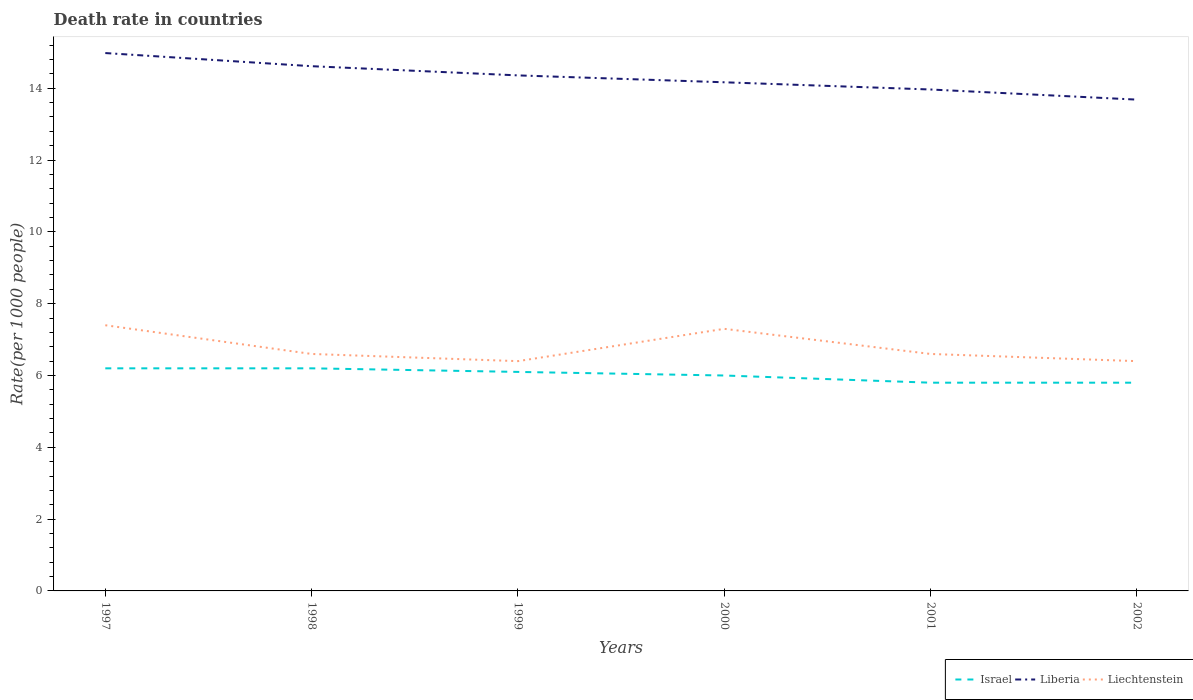How many different coloured lines are there?
Offer a terse response. 3. Is the number of lines equal to the number of legend labels?
Offer a very short reply. Yes. Across all years, what is the maximum death rate in Israel?
Ensure brevity in your answer.  5.8. In which year was the death rate in Israel maximum?
Ensure brevity in your answer.  2001. What is the total death rate in Liechtenstein in the graph?
Offer a very short reply. 0.1. What is the difference between the highest and the second highest death rate in Liberia?
Offer a very short reply. 1.3. What is the difference between the highest and the lowest death rate in Liberia?
Provide a succinct answer. 3. How many lines are there?
Keep it short and to the point. 3. Are the values on the major ticks of Y-axis written in scientific E-notation?
Your answer should be compact. No. Where does the legend appear in the graph?
Offer a very short reply. Bottom right. How many legend labels are there?
Provide a succinct answer. 3. What is the title of the graph?
Offer a terse response. Death rate in countries. Does "Iran" appear as one of the legend labels in the graph?
Your answer should be very brief. No. What is the label or title of the Y-axis?
Provide a short and direct response. Rate(per 1000 people). What is the Rate(per 1000 people) of Liberia in 1997?
Ensure brevity in your answer.  14.98. What is the Rate(per 1000 people) of Liechtenstein in 1997?
Make the answer very short. 7.4. What is the Rate(per 1000 people) in Israel in 1998?
Offer a terse response. 6.2. What is the Rate(per 1000 people) of Liberia in 1998?
Your response must be concise. 14.62. What is the Rate(per 1000 people) of Liberia in 1999?
Your answer should be very brief. 14.36. What is the Rate(per 1000 people) of Liechtenstein in 1999?
Offer a very short reply. 6.4. What is the Rate(per 1000 people) in Liberia in 2000?
Your answer should be very brief. 14.17. What is the Rate(per 1000 people) of Liechtenstein in 2000?
Provide a succinct answer. 7.3. What is the Rate(per 1000 people) of Israel in 2001?
Keep it short and to the point. 5.8. What is the Rate(per 1000 people) of Liberia in 2001?
Your answer should be very brief. 13.97. What is the Rate(per 1000 people) of Liechtenstein in 2001?
Ensure brevity in your answer.  6.6. What is the Rate(per 1000 people) in Israel in 2002?
Offer a very short reply. 5.8. What is the Rate(per 1000 people) of Liberia in 2002?
Provide a succinct answer. 13.68. What is the Rate(per 1000 people) in Liechtenstein in 2002?
Ensure brevity in your answer.  6.4. Across all years, what is the maximum Rate(per 1000 people) of Liberia?
Offer a very short reply. 14.98. Across all years, what is the maximum Rate(per 1000 people) in Liechtenstein?
Provide a short and direct response. 7.4. Across all years, what is the minimum Rate(per 1000 people) of Liberia?
Your response must be concise. 13.68. Across all years, what is the minimum Rate(per 1000 people) of Liechtenstein?
Give a very brief answer. 6.4. What is the total Rate(per 1000 people) in Israel in the graph?
Your response must be concise. 36.1. What is the total Rate(per 1000 people) of Liberia in the graph?
Ensure brevity in your answer.  85.77. What is the total Rate(per 1000 people) in Liechtenstein in the graph?
Your answer should be very brief. 40.7. What is the difference between the Rate(per 1000 people) of Liberia in 1997 and that in 1998?
Your answer should be very brief. 0.37. What is the difference between the Rate(per 1000 people) in Liechtenstein in 1997 and that in 1998?
Keep it short and to the point. 0.8. What is the difference between the Rate(per 1000 people) of Israel in 1997 and that in 1999?
Make the answer very short. 0.1. What is the difference between the Rate(per 1000 people) in Liberia in 1997 and that in 1999?
Provide a short and direct response. 0.62. What is the difference between the Rate(per 1000 people) of Liechtenstein in 1997 and that in 1999?
Offer a terse response. 1. What is the difference between the Rate(per 1000 people) of Israel in 1997 and that in 2000?
Ensure brevity in your answer.  0.2. What is the difference between the Rate(per 1000 people) in Liberia in 1997 and that in 2000?
Give a very brief answer. 0.81. What is the difference between the Rate(per 1000 people) of Israel in 1997 and that in 2001?
Ensure brevity in your answer.  0.4. What is the difference between the Rate(per 1000 people) in Liberia in 1997 and that in 2001?
Make the answer very short. 1.01. What is the difference between the Rate(per 1000 people) in Liechtenstein in 1997 and that in 2001?
Offer a terse response. 0.8. What is the difference between the Rate(per 1000 people) in Israel in 1997 and that in 2002?
Ensure brevity in your answer.  0.4. What is the difference between the Rate(per 1000 people) in Liberia in 1997 and that in 2002?
Provide a short and direct response. 1.3. What is the difference between the Rate(per 1000 people) in Liberia in 1998 and that in 1999?
Give a very brief answer. 0.26. What is the difference between the Rate(per 1000 people) of Liechtenstein in 1998 and that in 1999?
Make the answer very short. 0.2. What is the difference between the Rate(per 1000 people) of Liberia in 1998 and that in 2000?
Give a very brief answer. 0.45. What is the difference between the Rate(per 1000 people) in Israel in 1998 and that in 2001?
Your answer should be compact. 0.4. What is the difference between the Rate(per 1000 people) in Liberia in 1998 and that in 2001?
Offer a very short reply. 0.65. What is the difference between the Rate(per 1000 people) of Liberia in 1999 and that in 2000?
Give a very brief answer. 0.19. What is the difference between the Rate(per 1000 people) in Liberia in 1999 and that in 2001?
Provide a succinct answer. 0.39. What is the difference between the Rate(per 1000 people) in Israel in 1999 and that in 2002?
Give a very brief answer. 0.3. What is the difference between the Rate(per 1000 people) in Liberia in 1999 and that in 2002?
Provide a succinct answer. 0.68. What is the difference between the Rate(per 1000 people) of Liechtenstein in 1999 and that in 2002?
Your response must be concise. 0. What is the difference between the Rate(per 1000 people) in Liberia in 2000 and that in 2001?
Provide a succinct answer. 0.2. What is the difference between the Rate(per 1000 people) in Israel in 2000 and that in 2002?
Offer a very short reply. 0.2. What is the difference between the Rate(per 1000 people) in Liberia in 2000 and that in 2002?
Your answer should be very brief. 0.48. What is the difference between the Rate(per 1000 people) of Liberia in 2001 and that in 2002?
Give a very brief answer. 0.28. What is the difference between the Rate(per 1000 people) in Liechtenstein in 2001 and that in 2002?
Provide a succinct answer. 0.2. What is the difference between the Rate(per 1000 people) of Israel in 1997 and the Rate(per 1000 people) of Liberia in 1998?
Offer a very short reply. -8.41. What is the difference between the Rate(per 1000 people) of Israel in 1997 and the Rate(per 1000 people) of Liechtenstein in 1998?
Give a very brief answer. -0.4. What is the difference between the Rate(per 1000 people) of Liberia in 1997 and the Rate(per 1000 people) of Liechtenstein in 1998?
Your answer should be compact. 8.38. What is the difference between the Rate(per 1000 people) in Israel in 1997 and the Rate(per 1000 people) in Liberia in 1999?
Your answer should be compact. -8.16. What is the difference between the Rate(per 1000 people) in Israel in 1997 and the Rate(per 1000 people) in Liechtenstein in 1999?
Offer a terse response. -0.2. What is the difference between the Rate(per 1000 people) in Liberia in 1997 and the Rate(per 1000 people) in Liechtenstein in 1999?
Offer a very short reply. 8.58. What is the difference between the Rate(per 1000 people) of Israel in 1997 and the Rate(per 1000 people) of Liberia in 2000?
Provide a succinct answer. -7.97. What is the difference between the Rate(per 1000 people) in Israel in 1997 and the Rate(per 1000 people) in Liechtenstein in 2000?
Give a very brief answer. -1.1. What is the difference between the Rate(per 1000 people) of Liberia in 1997 and the Rate(per 1000 people) of Liechtenstein in 2000?
Keep it short and to the point. 7.68. What is the difference between the Rate(per 1000 people) of Israel in 1997 and the Rate(per 1000 people) of Liberia in 2001?
Offer a terse response. -7.77. What is the difference between the Rate(per 1000 people) in Liberia in 1997 and the Rate(per 1000 people) in Liechtenstein in 2001?
Your answer should be compact. 8.38. What is the difference between the Rate(per 1000 people) in Israel in 1997 and the Rate(per 1000 people) in Liberia in 2002?
Make the answer very short. -7.48. What is the difference between the Rate(per 1000 people) in Israel in 1997 and the Rate(per 1000 people) in Liechtenstein in 2002?
Keep it short and to the point. -0.2. What is the difference between the Rate(per 1000 people) of Liberia in 1997 and the Rate(per 1000 people) of Liechtenstein in 2002?
Your answer should be compact. 8.58. What is the difference between the Rate(per 1000 people) of Israel in 1998 and the Rate(per 1000 people) of Liberia in 1999?
Offer a very short reply. -8.16. What is the difference between the Rate(per 1000 people) in Israel in 1998 and the Rate(per 1000 people) in Liechtenstein in 1999?
Make the answer very short. -0.2. What is the difference between the Rate(per 1000 people) of Liberia in 1998 and the Rate(per 1000 people) of Liechtenstein in 1999?
Your answer should be very brief. 8.21. What is the difference between the Rate(per 1000 people) in Israel in 1998 and the Rate(per 1000 people) in Liberia in 2000?
Keep it short and to the point. -7.97. What is the difference between the Rate(per 1000 people) of Liberia in 1998 and the Rate(per 1000 people) of Liechtenstein in 2000?
Your answer should be very brief. 7.32. What is the difference between the Rate(per 1000 people) in Israel in 1998 and the Rate(per 1000 people) in Liberia in 2001?
Provide a short and direct response. -7.77. What is the difference between the Rate(per 1000 people) of Liberia in 1998 and the Rate(per 1000 people) of Liechtenstein in 2001?
Keep it short and to the point. 8.02. What is the difference between the Rate(per 1000 people) of Israel in 1998 and the Rate(per 1000 people) of Liberia in 2002?
Make the answer very short. -7.48. What is the difference between the Rate(per 1000 people) of Israel in 1998 and the Rate(per 1000 people) of Liechtenstein in 2002?
Offer a terse response. -0.2. What is the difference between the Rate(per 1000 people) in Liberia in 1998 and the Rate(per 1000 people) in Liechtenstein in 2002?
Your answer should be compact. 8.21. What is the difference between the Rate(per 1000 people) in Israel in 1999 and the Rate(per 1000 people) in Liberia in 2000?
Your answer should be compact. -8.07. What is the difference between the Rate(per 1000 people) of Liberia in 1999 and the Rate(per 1000 people) of Liechtenstein in 2000?
Make the answer very short. 7.06. What is the difference between the Rate(per 1000 people) in Israel in 1999 and the Rate(per 1000 people) in Liberia in 2001?
Your answer should be compact. -7.87. What is the difference between the Rate(per 1000 people) of Liberia in 1999 and the Rate(per 1000 people) of Liechtenstein in 2001?
Provide a succinct answer. 7.76. What is the difference between the Rate(per 1000 people) in Israel in 1999 and the Rate(per 1000 people) in Liberia in 2002?
Provide a succinct answer. -7.58. What is the difference between the Rate(per 1000 people) in Israel in 1999 and the Rate(per 1000 people) in Liechtenstein in 2002?
Give a very brief answer. -0.3. What is the difference between the Rate(per 1000 people) in Liberia in 1999 and the Rate(per 1000 people) in Liechtenstein in 2002?
Your answer should be very brief. 7.96. What is the difference between the Rate(per 1000 people) of Israel in 2000 and the Rate(per 1000 people) of Liberia in 2001?
Make the answer very short. -7.97. What is the difference between the Rate(per 1000 people) of Israel in 2000 and the Rate(per 1000 people) of Liechtenstein in 2001?
Keep it short and to the point. -0.6. What is the difference between the Rate(per 1000 people) in Liberia in 2000 and the Rate(per 1000 people) in Liechtenstein in 2001?
Offer a terse response. 7.57. What is the difference between the Rate(per 1000 people) of Israel in 2000 and the Rate(per 1000 people) of Liberia in 2002?
Give a very brief answer. -7.68. What is the difference between the Rate(per 1000 people) in Israel in 2000 and the Rate(per 1000 people) in Liechtenstein in 2002?
Your answer should be compact. -0.4. What is the difference between the Rate(per 1000 people) in Liberia in 2000 and the Rate(per 1000 people) in Liechtenstein in 2002?
Your answer should be compact. 7.77. What is the difference between the Rate(per 1000 people) of Israel in 2001 and the Rate(per 1000 people) of Liberia in 2002?
Ensure brevity in your answer.  -7.88. What is the difference between the Rate(per 1000 people) in Liberia in 2001 and the Rate(per 1000 people) in Liechtenstein in 2002?
Keep it short and to the point. 7.57. What is the average Rate(per 1000 people) in Israel per year?
Your answer should be compact. 6.02. What is the average Rate(per 1000 people) in Liberia per year?
Ensure brevity in your answer.  14.3. What is the average Rate(per 1000 people) of Liechtenstein per year?
Your answer should be compact. 6.78. In the year 1997, what is the difference between the Rate(per 1000 people) of Israel and Rate(per 1000 people) of Liberia?
Your answer should be very brief. -8.78. In the year 1997, what is the difference between the Rate(per 1000 people) of Israel and Rate(per 1000 people) of Liechtenstein?
Ensure brevity in your answer.  -1.2. In the year 1997, what is the difference between the Rate(per 1000 people) in Liberia and Rate(per 1000 people) in Liechtenstein?
Ensure brevity in your answer.  7.58. In the year 1998, what is the difference between the Rate(per 1000 people) in Israel and Rate(per 1000 people) in Liberia?
Your answer should be compact. -8.41. In the year 1998, what is the difference between the Rate(per 1000 people) in Israel and Rate(per 1000 people) in Liechtenstein?
Give a very brief answer. -0.4. In the year 1998, what is the difference between the Rate(per 1000 people) in Liberia and Rate(per 1000 people) in Liechtenstein?
Your answer should be very brief. 8.02. In the year 1999, what is the difference between the Rate(per 1000 people) in Israel and Rate(per 1000 people) in Liberia?
Provide a short and direct response. -8.26. In the year 1999, what is the difference between the Rate(per 1000 people) of Liberia and Rate(per 1000 people) of Liechtenstein?
Your answer should be very brief. 7.96. In the year 2000, what is the difference between the Rate(per 1000 people) in Israel and Rate(per 1000 people) in Liberia?
Your answer should be compact. -8.17. In the year 2000, what is the difference between the Rate(per 1000 people) of Israel and Rate(per 1000 people) of Liechtenstein?
Your response must be concise. -1.3. In the year 2000, what is the difference between the Rate(per 1000 people) in Liberia and Rate(per 1000 people) in Liechtenstein?
Your answer should be compact. 6.87. In the year 2001, what is the difference between the Rate(per 1000 people) of Israel and Rate(per 1000 people) of Liberia?
Ensure brevity in your answer.  -8.17. In the year 2001, what is the difference between the Rate(per 1000 people) in Liberia and Rate(per 1000 people) in Liechtenstein?
Your answer should be compact. 7.37. In the year 2002, what is the difference between the Rate(per 1000 people) in Israel and Rate(per 1000 people) in Liberia?
Provide a succinct answer. -7.88. In the year 2002, what is the difference between the Rate(per 1000 people) in Israel and Rate(per 1000 people) in Liechtenstein?
Keep it short and to the point. -0.6. In the year 2002, what is the difference between the Rate(per 1000 people) of Liberia and Rate(per 1000 people) of Liechtenstein?
Provide a short and direct response. 7.28. What is the ratio of the Rate(per 1000 people) of Israel in 1997 to that in 1998?
Offer a terse response. 1. What is the ratio of the Rate(per 1000 people) in Liechtenstein in 1997 to that in 1998?
Keep it short and to the point. 1.12. What is the ratio of the Rate(per 1000 people) in Israel in 1997 to that in 1999?
Provide a succinct answer. 1.02. What is the ratio of the Rate(per 1000 people) of Liberia in 1997 to that in 1999?
Give a very brief answer. 1.04. What is the ratio of the Rate(per 1000 people) in Liechtenstein in 1997 to that in 1999?
Your response must be concise. 1.16. What is the ratio of the Rate(per 1000 people) in Israel in 1997 to that in 2000?
Offer a very short reply. 1.03. What is the ratio of the Rate(per 1000 people) of Liberia in 1997 to that in 2000?
Provide a short and direct response. 1.06. What is the ratio of the Rate(per 1000 people) in Liechtenstein in 1997 to that in 2000?
Ensure brevity in your answer.  1.01. What is the ratio of the Rate(per 1000 people) of Israel in 1997 to that in 2001?
Offer a terse response. 1.07. What is the ratio of the Rate(per 1000 people) of Liberia in 1997 to that in 2001?
Your answer should be compact. 1.07. What is the ratio of the Rate(per 1000 people) in Liechtenstein in 1997 to that in 2001?
Make the answer very short. 1.12. What is the ratio of the Rate(per 1000 people) in Israel in 1997 to that in 2002?
Keep it short and to the point. 1.07. What is the ratio of the Rate(per 1000 people) of Liberia in 1997 to that in 2002?
Make the answer very short. 1.09. What is the ratio of the Rate(per 1000 people) of Liechtenstein in 1997 to that in 2002?
Your answer should be very brief. 1.16. What is the ratio of the Rate(per 1000 people) of Israel in 1998 to that in 1999?
Give a very brief answer. 1.02. What is the ratio of the Rate(per 1000 people) in Liberia in 1998 to that in 1999?
Your response must be concise. 1.02. What is the ratio of the Rate(per 1000 people) of Liechtenstein in 1998 to that in 1999?
Your answer should be compact. 1.03. What is the ratio of the Rate(per 1000 people) in Israel in 1998 to that in 2000?
Provide a short and direct response. 1.03. What is the ratio of the Rate(per 1000 people) in Liberia in 1998 to that in 2000?
Offer a very short reply. 1.03. What is the ratio of the Rate(per 1000 people) of Liechtenstein in 1998 to that in 2000?
Offer a terse response. 0.9. What is the ratio of the Rate(per 1000 people) in Israel in 1998 to that in 2001?
Provide a short and direct response. 1.07. What is the ratio of the Rate(per 1000 people) in Liberia in 1998 to that in 2001?
Your response must be concise. 1.05. What is the ratio of the Rate(per 1000 people) in Liechtenstein in 1998 to that in 2001?
Your response must be concise. 1. What is the ratio of the Rate(per 1000 people) of Israel in 1998 to that in 2002?
Your answer should be very brief. 1.07. What is the ratio of the Rate(per 1000 people) in Liberia in 1998 to that in 2002?
Give a very brief answer. 1.07. What is the ratio of the Rate(per 1000 people) in Liechtenstein in 1998 to that in 2002?
Your answer should be very brief. 1.03. What is the ratio of the Rate(per 1000 people) of Israel in 1999 to that in 2000?
Your answer should be very brief. 1.02. What is the ratio of the Rate(per 1000 people) in Liberia in 1999 to that in 2000?
Provide a succinct answer. 1.01. What is the ratio of the Rate(per 1000 people) in Liechtenstein in 1999 to that in 2000?
Your response must be concise. 0.88. What is the ratio of the Rate(per 1000 people) of Israel in 1999 to that in 2001?
Provide a succinct answer. 1.05. What is the ratio of the Rate(per 1000 people) in Liberia in 1999 to that in 2001?
Your response must be concise. 1.03. What is the ratio of the Rate(per 1000 people) of Liechtenstein in 1999 to that in 2001?
Ensure brevity in your answer.  0.97. What is the ratio of the Rate(per 1000 people) in Israel in 1999 to that in 2002?
Your answer should be compact. 1.05. What is the ratio of the Rate(per 1000 people) in Liberia in 1999 to that in 2002?
Your answer should be compact. 1.05. What is the ratio of the Rate(per 1000 people) in Israel in 2000 to that in 2001?
Ensure brevity in your answer.  1.03. What is the ratio of the Rate(per 1000 people) in Liberia in 2000 to that in 2001?
Offer a very short reply. 1.01. What is the ratio of the Rate(per 1000 people) of Liechtenstein in 2000 to that in 2001?
Your response must be concise. 1.11. What is the ratio of the Rate(per 1000 people) of Israel in 2000 to that in 2002?
Your response must be concise. 1.03. What is the ratio of the Rate(per 1000 people) in Liberia in 2000 to that in 2002?
Your answer should be compact. 1.04. What is the ratio of the Rate(per 1000 people) in Liechtenstein in 2000 to that in 2002?
Your answer should be very brief. 1.14. What is the ratio of the Rate(per 1000 people) in Israel in 2001 to that in 2002?
Offer a very short reply. 1. What is the ratio of the Rate(per 1000 people) of Liberia in 2001 to that in 2002?
Keep it short and to the point. 1.02. What is the ratio of the Rate(per 1000 people) in Liechtenstein in 2001 to that in 2002?
Offer a very short reply. 1.03. What is the difference between the highest and the second highest Rate(per 1000 people) in Israel?
Give a very brief answer. 0. What is the difference between the highest and the second highest Rate(per 1000 people) in Liberia?
Provide a short and direct response. 0.37. What is the difference between the highest and the lowest Rate(per 1000 people) of Israel?
Ensure brevity in your answer.  0.4. What is the difference between the highest and the lowest Rate(per 1000 people) of Liberia?
Give a very brief answer. 1.3. What is the difference between the highest and the lowest Rate(per 1000 people) in Liechtenstein?
Your response must be concise. 1. 